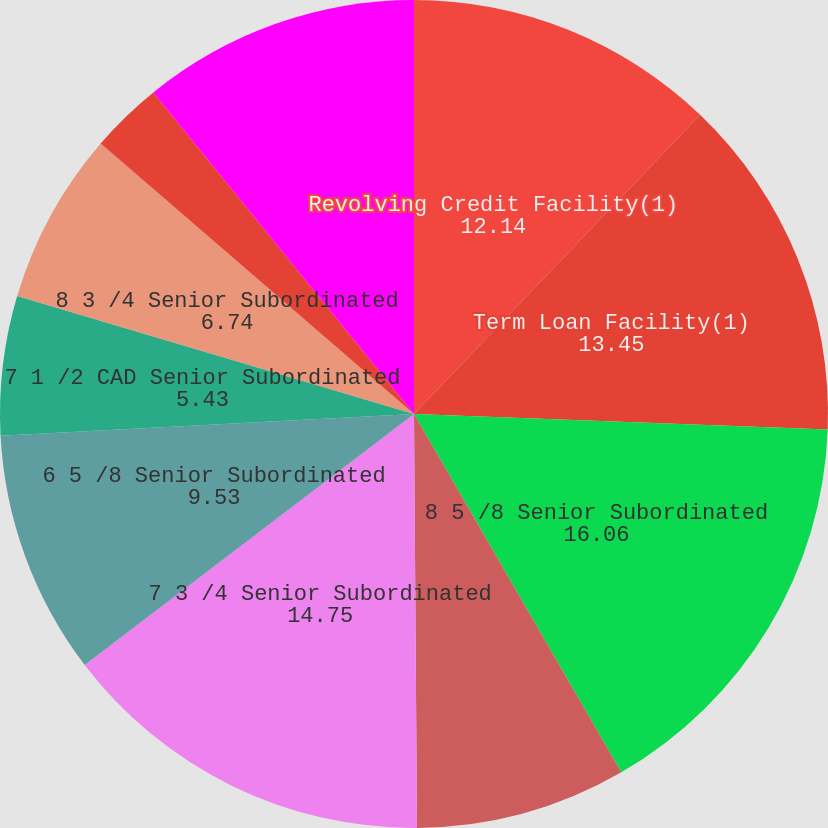<chart> <loc_0><loc_0><loc_500><loc_500><pie_chart><fcel>Revolving Credit Facility(1)<fcel>Term Loan Facility(1)<fcel>8 5 /8 Senior Subordinated<fcel>7 1 /4 GBP Senior Subordinated<fcel>7 3 /4 Senior Subordinated<fcel>6 5 /8 Senior Subordinated<fcel>7 1 /2 CAD Senior Subordinated<fcel>8 3 /4 Senior Subordinated<fcel>8 Senior Subordinated Notes<fcel>6 3 /4 Euro Senior<nl><fcel>12.14%<fcel>13.45%<fcel>16.06%<fcel>8.23%<fcel>14.75%<fcel>9.53%<fcel>5.43%<fcel>6.74%<fcel>2.82%<fcel>10.84%<nl></chart> 